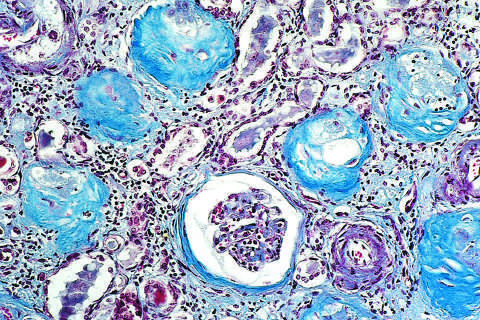how does a masson trichrome preparation show complete replacement of virtually all glomeruli?
Answer the question using a single word or phrase. By blue-staining collagen 